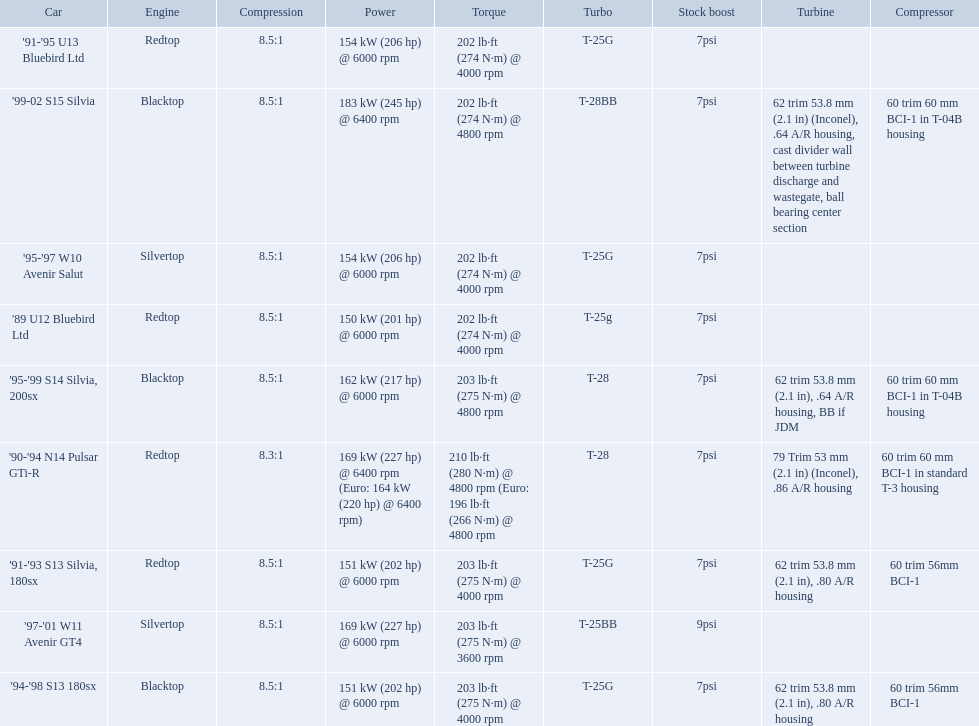Which cars featured blacktop engines? '94-'98 S13 180sx, '95-'99 S14 Silvia, 200sx, '99-02 S15 Silvia. Which of these had t-04b compressor housings? '95-'99 S14 Silvia, 200sx, '99-02 S15 Silvia. Which one of these has the highest horsepower? '99-02 S15 Silvia. What are all of the cars? '89 U12 Bluebird Ltd, '91-'95 U13 Bluebird Ltd, '95-'97 W10 Avenir Salut, '97-'01 W11 Avenir GT4, '90-'94 N14 Pulsar GTi-R, '91-'93 S13 Silvia, 180sx, '94-'98 S13 180sx, '95-'99 S14 Silvia, 200sx, '99-02 S15 Silvia. What is their rated power? 150 kW (201 hp) @ 6000 rpm, 154 kW (206 hp) @ 6000 rpm, 154 kW (206 hp) @ 6000 rpm, 169 kW (227 hp) @ 6000 rpm, 169 kW (227 hp) @ 6400 rpm (Euro: 164 kW (220 hp) @ 6400 rpm), 151 kW (202 hp) @ 6000 rpm, 151 kW (202 hp) @ 6000 rpm, 162 kW (217 hp) @ 6000 rpm, 183 kW (245 hp) @ 6400 rpm. Which car has the most power? '99-02 S15 Silvia. 